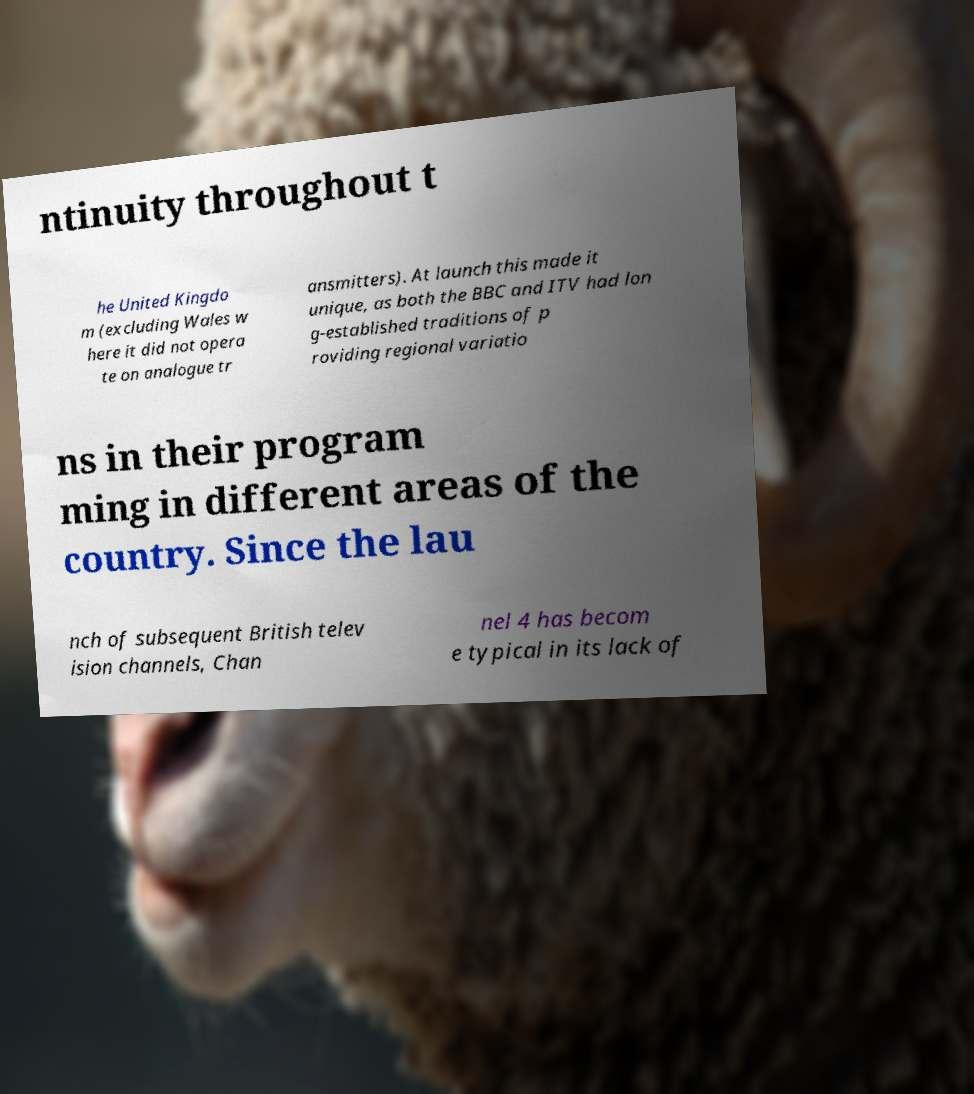Can you accurately transcribe the text from the provided image for me? ntinuity throughout t he United Kingdo m (excluding Wales w here it did not opera te on analogue tr ansmitters). At launch this made it unique, as both the BBC and ITV had lon g-established traditions of p roviding regional variatio ns in their program ming in different areas of the country. Since the lau nch of subsequent British telev ision channels, Chan nel 4 has becom e typical in its lack of 